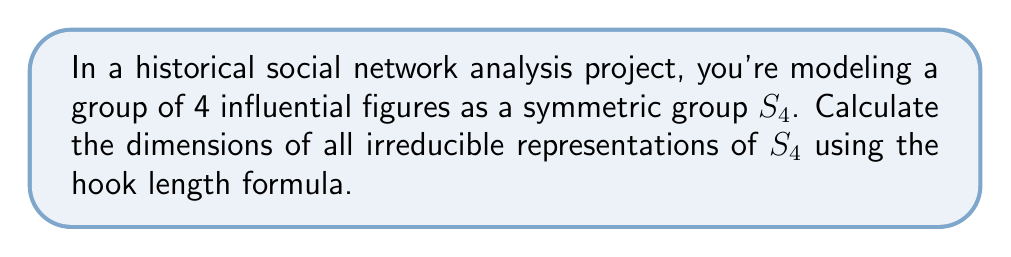What is the answer to this math problem? To calculate the dimensions of irreducible representations for $S_4$, we'll use the following steps:

1. Identify the partitions of 4, which correspond to the irreducible representations of $S_4$.
2. For each partition, create its Young diagram.
3. Apply the hook length formula to each diagram.

Step 1: Partitions of 4
The partitions of 4 are: [4], [3,1], [2,2], [2,1,1], [1,1,1,1]

Step 2: Young diagrams
For each partition, we create its Young diagram:

[asy]
unitsize(0.5cm);
void drawYoung(int[] p) {
  for(int i = 0; i < p.length; ++i) {
    for(int j = 0; j < p[i]; ++j) {
      draw((j,-i)--(j+1,-i)--(j+1,-i-1)--(j,-i-1)--cycle);
    }
  }
}
drawYoung(new int[]{4});
label("[4]", (2,-1.5));
drawYoung(new int[]{3,1});
label("[3,1]", (2,-2.5));
shift(5,0);
drawYoung(new int[]{2,2});
label("[2,2]", (1,-2.5));
shift(3,0);
drawYoung(new int[]{2,1,1});
label("[2,1,1]", (1,-3.5));
shift(3,0);
drawYoung(new int[]{1,1,1,1});
label("[1,1,1,1]", (0.5,-4.5));
[/asy]

Step 3: Hook length formula
The hook length formula states that the dimension of an irreducible representation is:

$$ \text{dim} = \frac{n!}{\prod_{(i,j)} h_{ij}} $$

where $n$ is the number of boxes, and $h_{ij}$ is the hook length of the box in the $i$-th row and $j$-th column.

For each partition:

[4]:
Hook lengths: 4, 3, 2, 1
$\text{dim} = \frac{4!}{4 \cdot 3 \cdot 2 \cdot 1} = 1$

[3,1]:
Hook lengths: 4, 2, 1, 1
$\text{dim} = \frac{4!}{4 \cdot 2 \cdot 1 \cdot 1} = 3$

[2,2]:
Hook lengths: 3, 2, 2, 1
$\text{dim} = \frac{4!}{3 \cdot 2 \cdot 2 \cdot 1} = 2$

[2,1,1]:
Hook lengths: 3, 1, 2, 1
$\text{dim} = \frac{4!}{3 \cdot 1 \cdot 2 \cdot 1} = 3$

[1,1,1,1]:
Hook lengths: 4, 3, 2, 1
$\text{dim} = \frac{4!}{4 \cdot 3 \cdot 2 \cdot 1} = 1$
Answer: The dimensions of irreducible representations of $S_4$ are: 1, 3, 2, 3, 1 